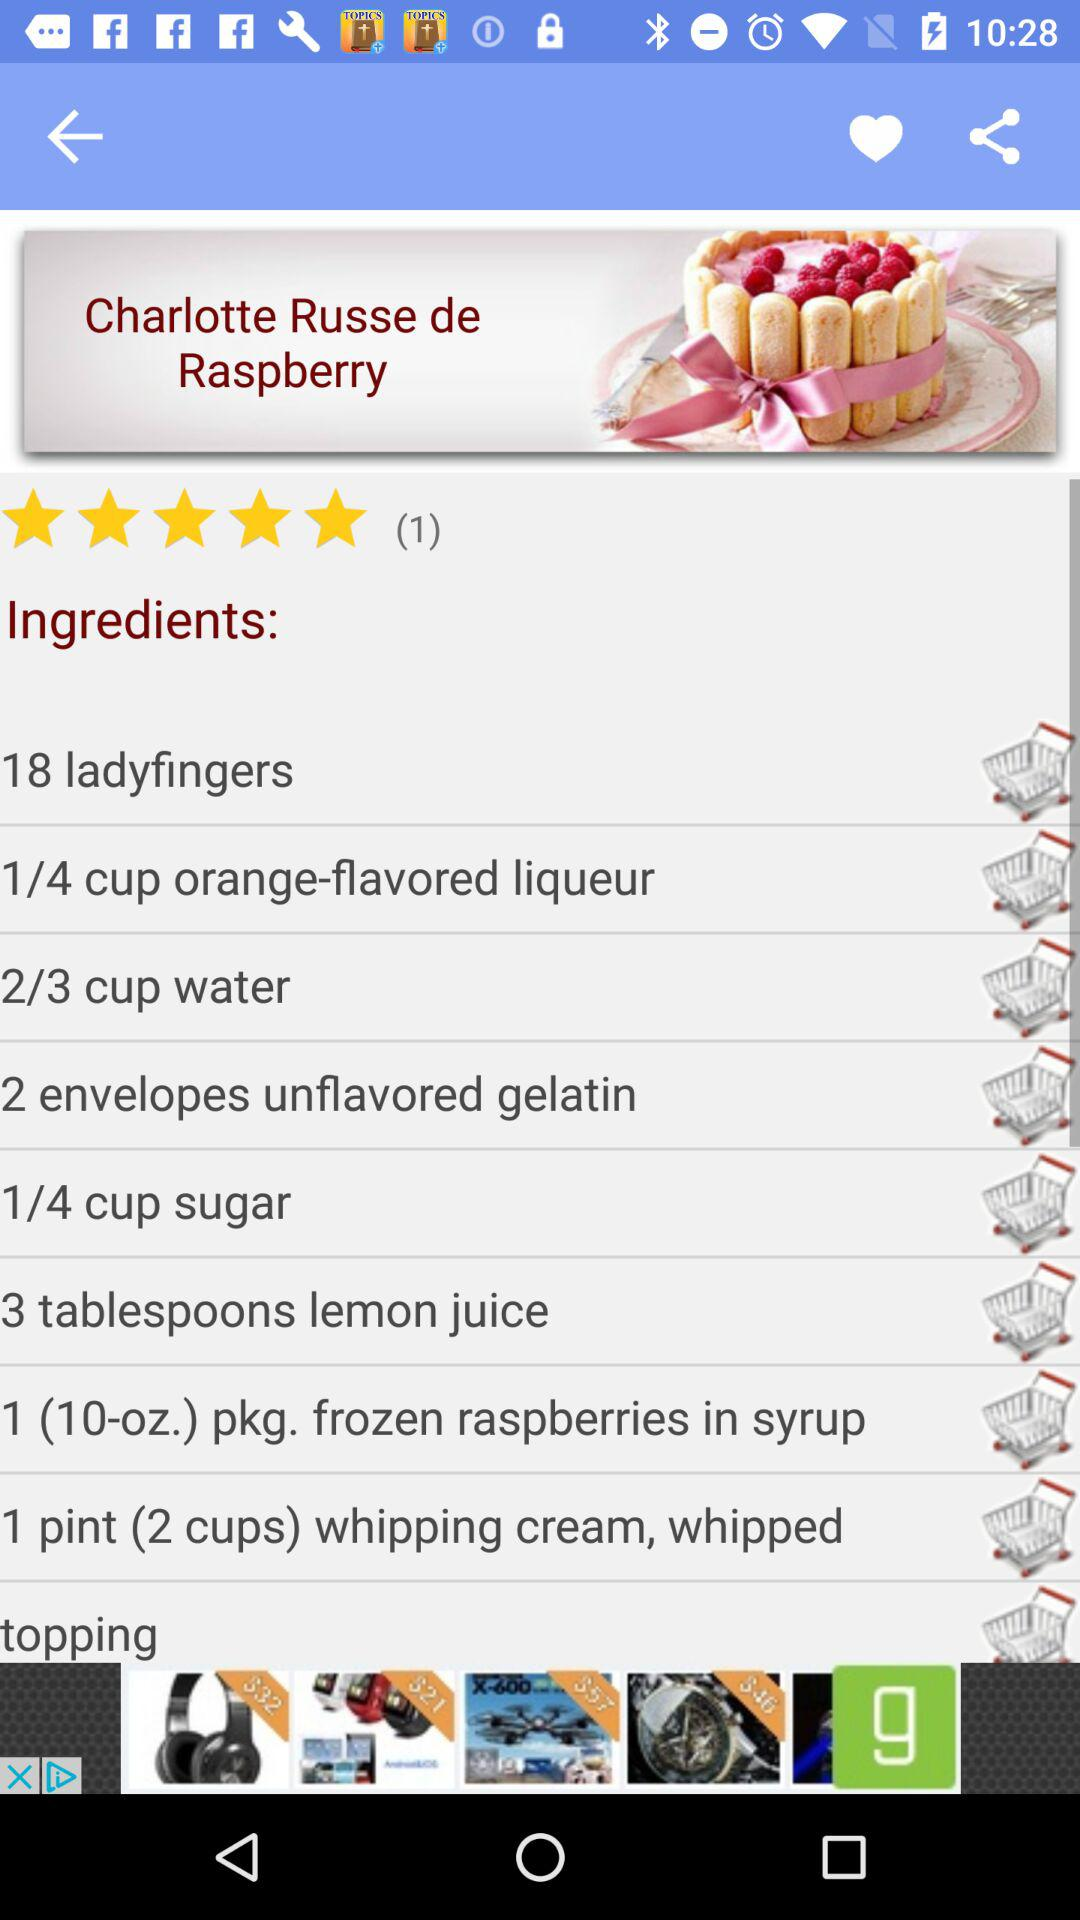What are the ingredients needed to make "Charlotte Russe de Raspberry"? The ingredients needed to make "Charlotte Russe de Raspberry" are 18 ladyfingers, 1/4 cup orange-flavored liqueur, 2/3 cup water, 2 envelopes unflavored gelatin, 1/4 cup sugar, 3 tablespoons lemon juice, 1 (10-oz.) pkg. frozen raspberries in syrup, 1 pint (2 cups) whipping cream (whipped) and topping. 